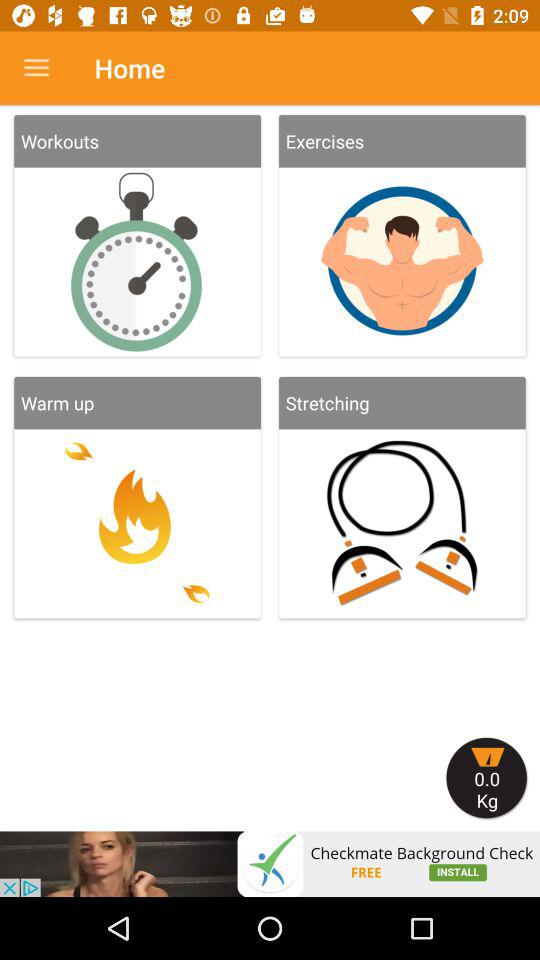What is the weight in kg? The weight is 0 kg. 